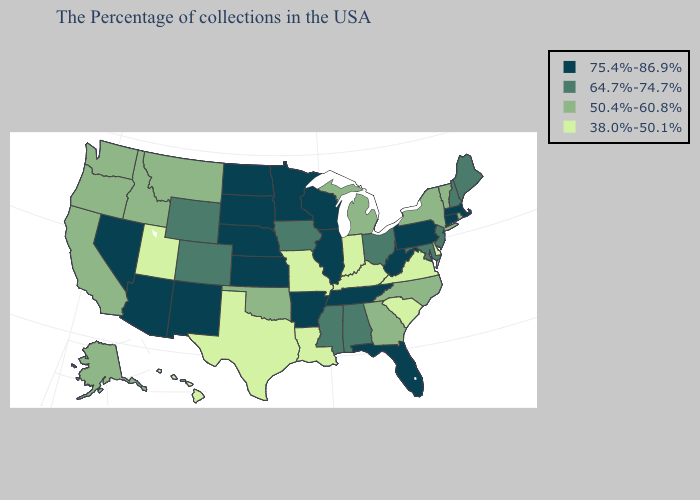Does Connecticut have the highest value in the Northeast?
Be succinct. Yes. Among the states that border Oregon , does Nevada have the lowest value?
Short answer required. No. Among the states that border Florida , which have the lowest value?
Quick response, please. Georgia. How many symbols are there in the legend?
Give a very brief answer. 4. What is the value of Delaware?
Short answer required. 38.0%-50.1%. Does Maryland have the lowest value in the USA?
Be succinct. No. What is the value of Wyoming?
Be succinct. 64.7%-74.7%. Does Mississippi have the same value as Kansas?
Keep it brief. No. Name the states that have a value in the range 75.4%-86.9%?
Concise answer only. Massachusetts, Connecticut, Pennsylvania, West Virginia, Florida, Tennessee, Wisconsin, Illinois, Arkansas, Minnesota, Kansas, Nebraska, South Dakota, North Dakota, New Mexico, Arizona, Nevada. Does the first symbol in the legend represent the smallest category?
Concise answer only. No. What is the value of Illinois?
Keep it brief. 75.4%-86.9%. Name the states that have a value in the range 75.4%-86.9%?
Short answer required. Massachusetts, Connecticut, Pennsylvania, West Virginia, Florida, Tennessee, Wisconsin, Illinois, Arkansas, Minnesota, Kansas, Nebraska, South Dakota, North Dakota, New Mexico, Arizona, Nevada. Which states hav the highest value in the Northeast?
Concise answer only. Massachusetts, Connecticut, Pennsylvania. 